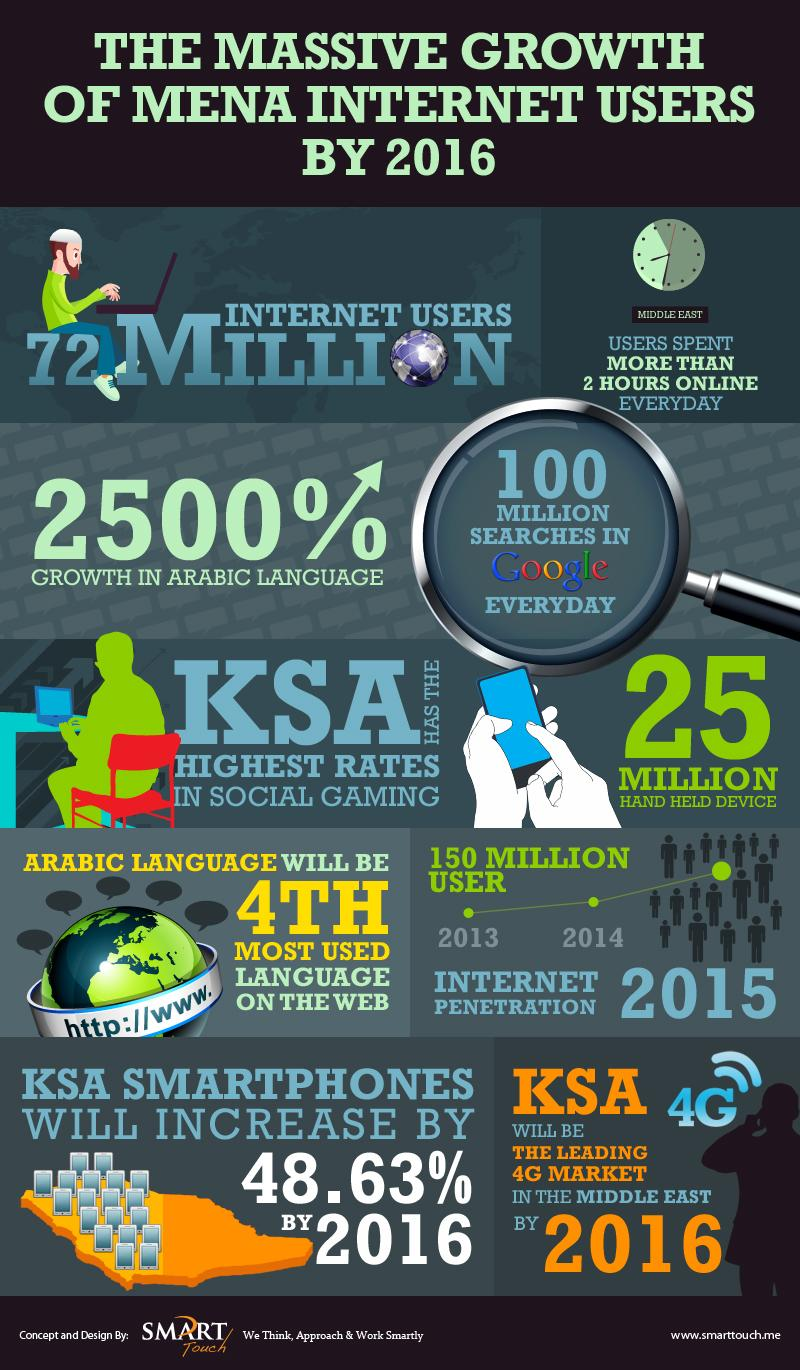Indicate a few pertinent items in this graphic. The number of users reached 150 million in the year 2015. 